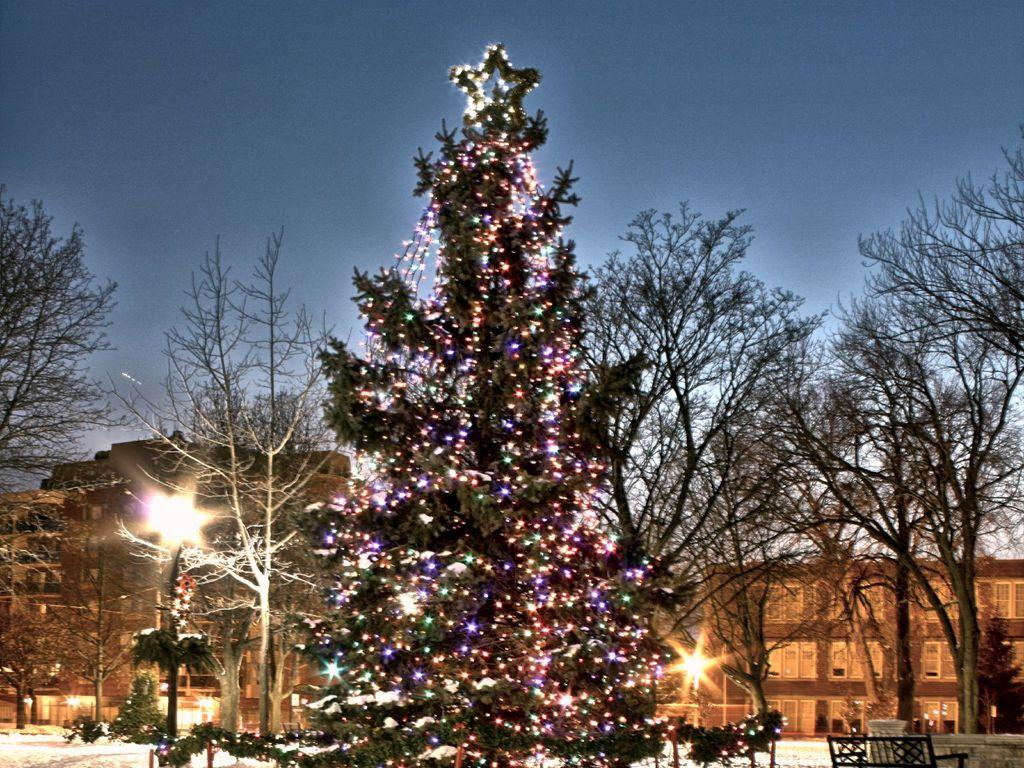What is the main object in the image? There is a tree in the image. How is the tree in the image decorated? The tree is decorated with lights and other things. What else can be seen in the image besides the tree? There are other buildings, trees, and benches in the image. Can you see a beggar sitting on one of the benches in the image? There is no beggar present in the image; it only shows a decorated tree, buildings, trees, and benches. 